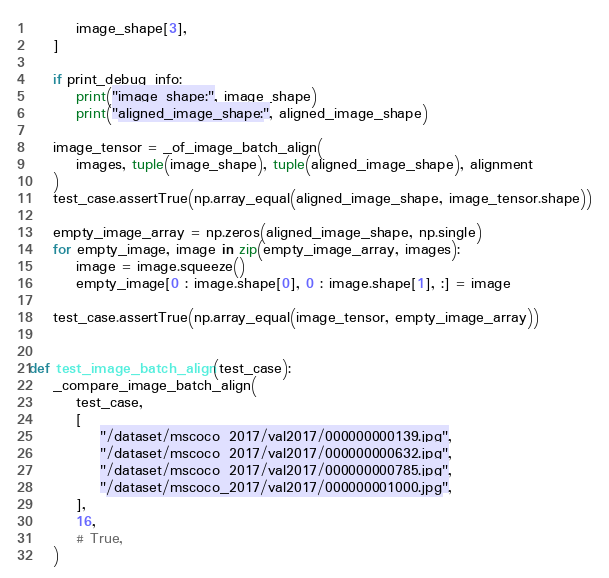<code> <loc_0><loc_0><loc_500><loc_500><_Python_>        image_shape[3],
    ]

    if print_debug_info:
        print("image_shape:", image_shape)
        print("aligned_image_shape:", aligned_image_shape)

    image_tensor = _of_image_batch_align(
        images, tuple(image_shape), tuple(aligned_image_shape), alignment
    )
    test_case.assertTrue(np.array_equal(aligned_image_shape, image_tensor.shape))

    empty_image_array = np.zeros(aligned_image_shape, np.single)
    for empty_image, image in zip(empty_image_array, images):
        image = image.squeeze()
        empty_image[0 : image.shape[0], 0 : image.shape[1], :] = image

    test_case.assertTrue(np.array_equal(image_tensor, empty_image_array))


def test_image_batch_align(test_case):
    _compare_image_batch_align(
        test_case,
        [
            "/dataset/mscoco_2017/val2017/000000000139.jpg",
            "/dataset/mscoco_2017/val2017/000000000632.jpg",
            "/dataset/mscoco_2017/val2017/000000000785.jpg",
            "/dataset/mscoco_2017/val2017/000000001000.jpg",
        ],
        16,
        # True,
    )
</code> 